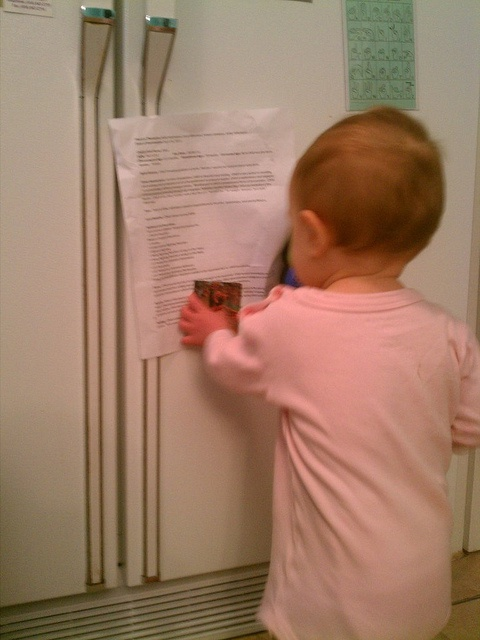Describe the objects in this image and their specific colors. I can see refrigerator in olive, tan, gray, and maroon tones and people in olive, salmon, and maroon tones in this image. 